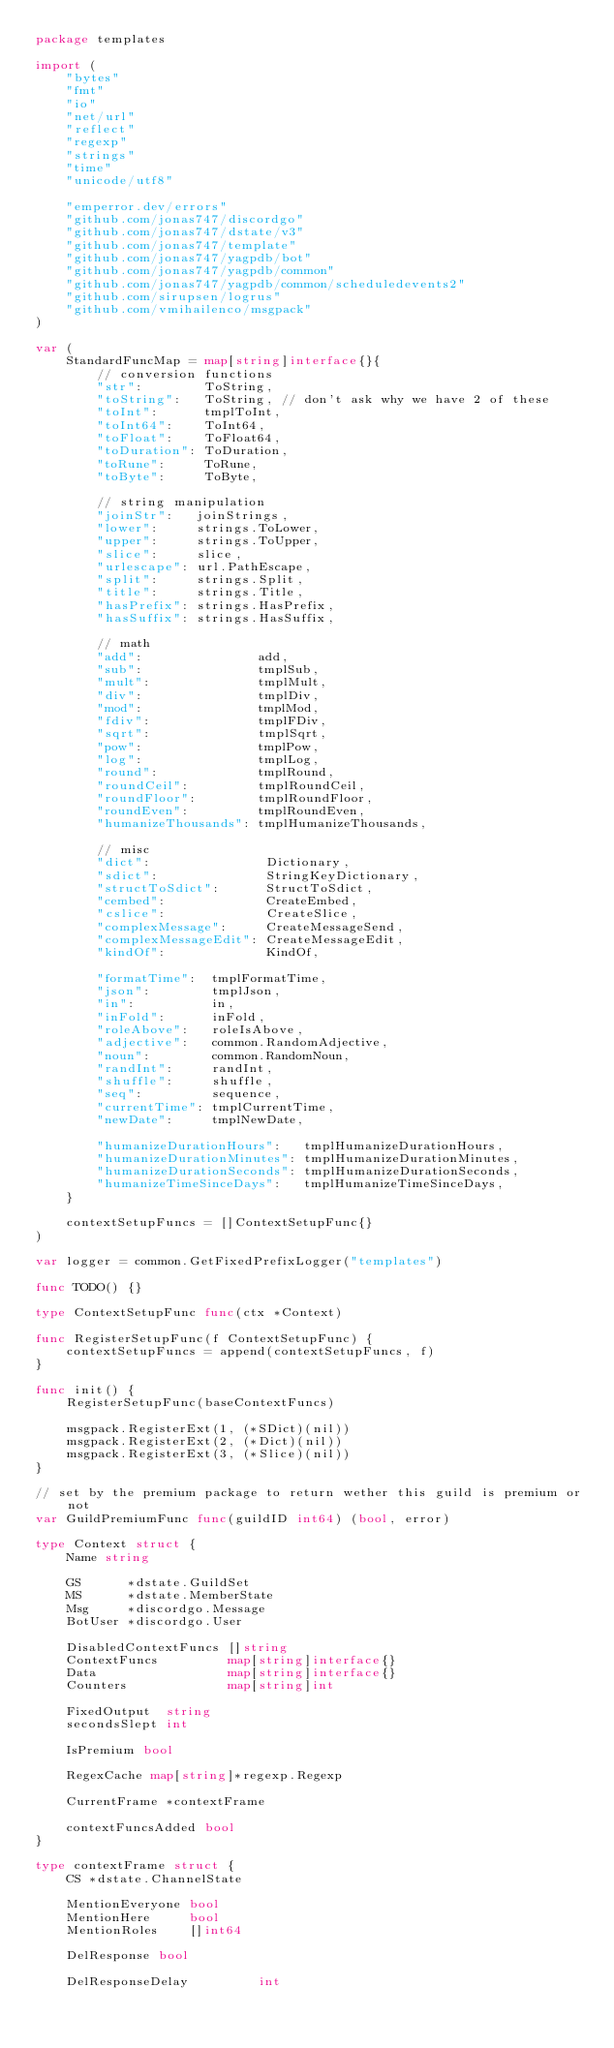Convert code to text. <code><loc_0><loc_0><loc_500><loc_500><_Go_>package templates

import (
	"bytes"
	"fmt"
	"io"
	"net/url"
	"reflect"
	"regexp"
	"strings"
	"time"
	"unicode/utf8"

	"emperror.dev/errors"
	"github.com/jonas747/discordgo"
	"github.com/jonas747/dstate/v3"
	"github.com/jonas747/template"
	"github.com/jonas747/yagpdb/bot"
	"github.com/jonas747/yagpdb/common"
	"github.com/jonas747/yagpdb/common/scheduledevents2"
	"github.com/sirupsen/logrus"
	"github.com/vmihailenco/msgpack"
)

var (
	StandardFuncMap = map[string]interface{}{
		// conversion functions
		"str":        ToString,
		"toString":   ToString, // don't ask why we have 2 of these
		"toInt":      tmplToInt,
		"toInt64":    ToInt64,
		"toFloat":    ToFloat64,
		"toDuration": ToDuration,
		"toRune":     ToRune,
		"toByte":     ToByte,

		// string manipulation
		"joinStr":   joinStrings,
		"lower":     strings.ToLower,
		"upper":     strings.ToUpper,
		"slice":     slice,
		"urlescape": url.PathEscape,
		"split":     strings.Split,
		"title":     strings.Title,
		"hasPrefix": strings.HasPrefix,
		"hasSuffix": strings.HasSuffix,

		// math
		"add":               add,
		"sub":               tmplSub,
		"mult":              tmplMult,
		"div":               tmplDiv,
		"mod":               tmplMod,
		"fdiv":              tmplFDiv,
		"sqrt":              tmplSqrt,
		"pow":               tmplPow,
		"log":               tmplLog,
		"round":             tmplRound,
		"roundCeil":         tmplRoundCeil,
		"roundFloor":        tmplRoundFloor,
		"roundEven":         tmplRoundEven,
		"humanizeThousands": tmplHumanizeThousands,

		// misc
		"dict":               Dictionary,
		"sdict":              StringKeyDictionary,
		"structToSdict":      StructToSdict,
		"cembed":             CreateEmbed,
		"cslice":             CreateSlice,
		"complexMessage":     CreateMessageSend,
		"complexMessageEdit": CreateMessageEdit,
		"kindOf":             KindOf,

		"formatTime":  tmplFormatTime,
		"json":        tmplJson,
		"in":          in,
		"inFold":      inFold,
		"roleAbove":   roleIsAbove,
		"adjective":   common.RandomAdjective,
		"noun":        common.RandomNoun,
		"randInt":     randInt,
		"shuffle":     shuffle,
		"seq":         sequence,
		"currentTime": tmplCurrentTime,
		"newDate":     tmplNewDate,

		"humanizeDurationHours":   tmplHumanizeDurationHours,
		"humanizeDurationMinutes": tmplHumanizeDurationMinutes,
		"humanizeDurationSeconds": tmplHumanizeDurationSeconds,
		"humanizeTimeSinceDays":   tmplHumanizeTimeSinceDays,
	}

	contextSetupFuncs = []ContextSetupFunc{}
)

var logger = common.GetFixedPrefixLogger("templates")

func TODO() {}

type ContextSetupFunc func(ctx *Context)

func RegisterSetupFunc(f ContextSetupFunc) {
	contextSetupFuncs = append(contextSetupFuncs, f)
}

func init() {
	RegisterSetupFunc(baseContextFuncs)

	msgpack.RegisterExt(1, (*SDict)(nil))
	msgpack.RegisterExt(2, (*Dict)(nil))
	msgpack.RegisterExt(3, (*Slice)(nil))
}

// set by the premium package to return wether this guild is premium or not
var GuildPremiumFunc func(guildID int64) (bool, error)

type Context struct {
	Name string

	GS      *dstate.GuildSet
	MS      *dstate.MemberState
	Msg     *discordgo.Message
	BotUser *discordgo.User

	DisabledContextFuncs []string
	ContextFuncs         map[string]interface{}
	Data                 map[string]interface{}
	Counters             map[string]int

	FixedOutput  string
	secondsSlept int

	IsPremium bool

	RegexCache map[string]*regexp.Regexp

	CurrentFrame *contextFrame

	contextFuncsAdded bool
}

type contextFrame struct {
	CS *dstate.ChannelState

	MentionEveryone bool
	MentionHere     bool
	MentionRoles    []int64

	DelResponse bool

	DelResponseDelay         int</code> 